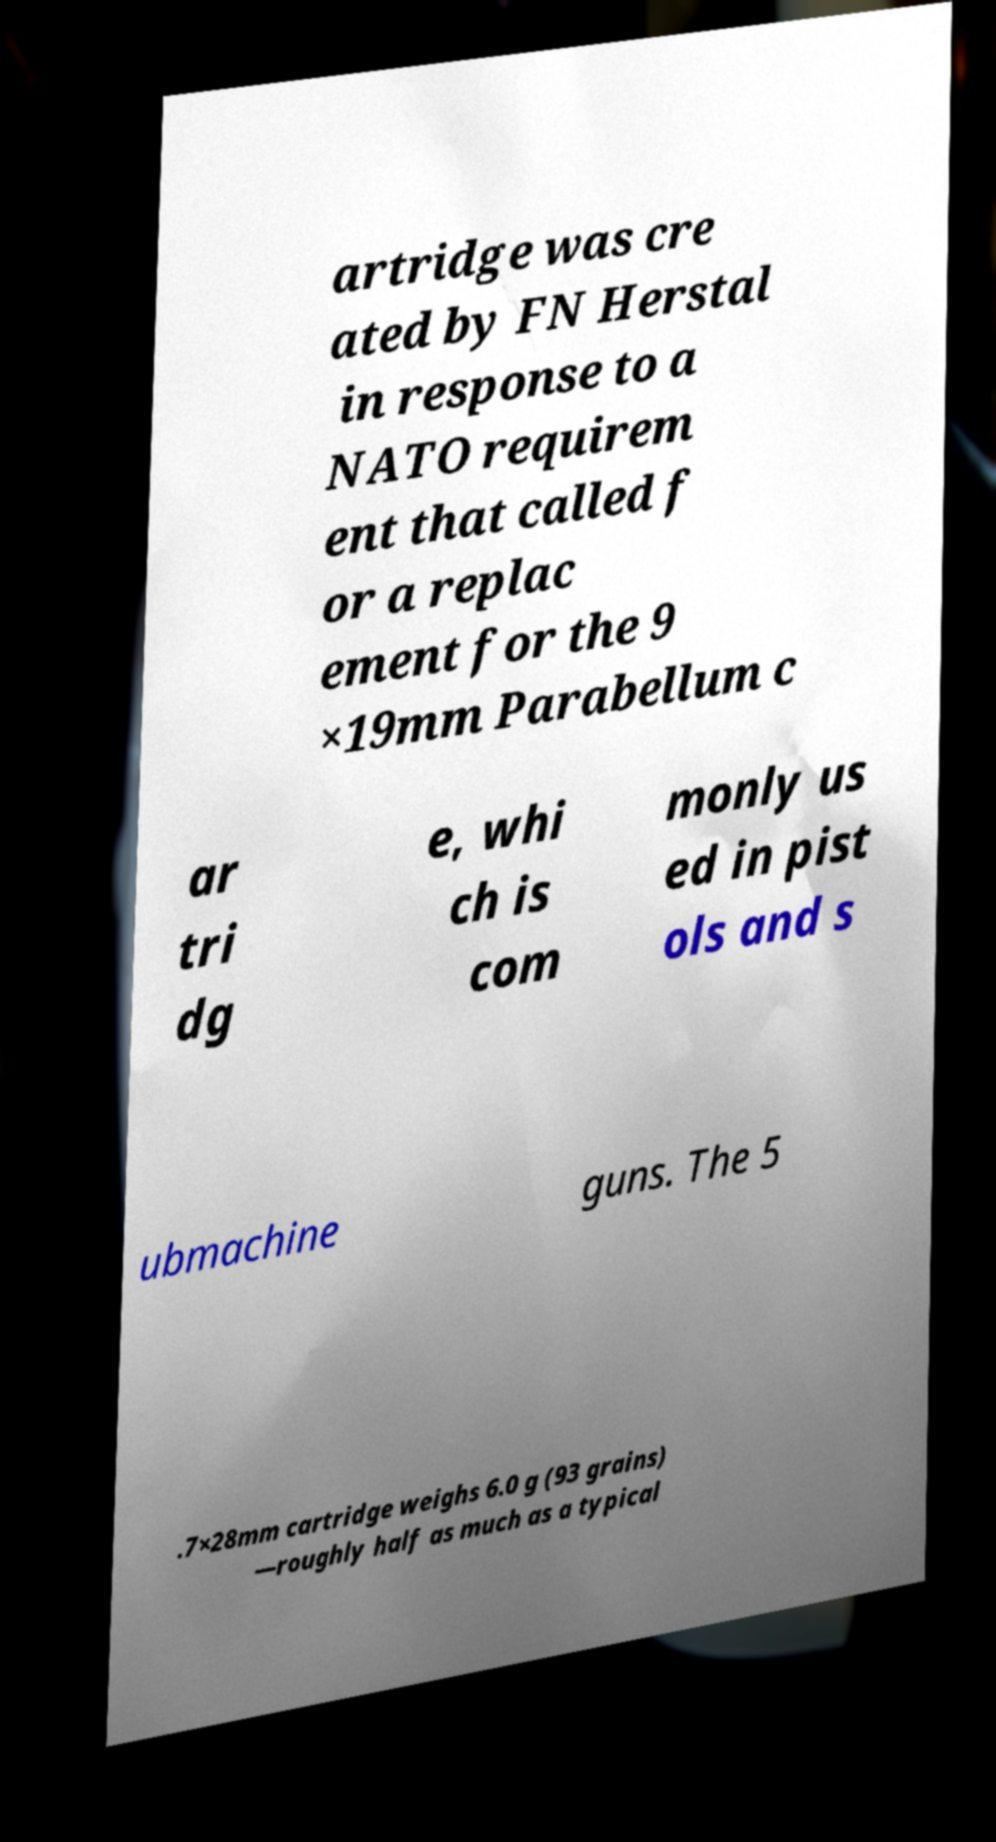Could you assist in decoding the text presented in this image and type it out clearly? artridge was cre ated by FN Herstal in response to a NATO requirem ent that called f or a replac ement for the 9 ×19mm Parabellum c ar tri dg e, whi ch is com monly us ed in pist ols and s ubmachine guns. The 5 .7×28mm cartridge weighs 6.0 g (93 grains) —roughly half as much as a typical 